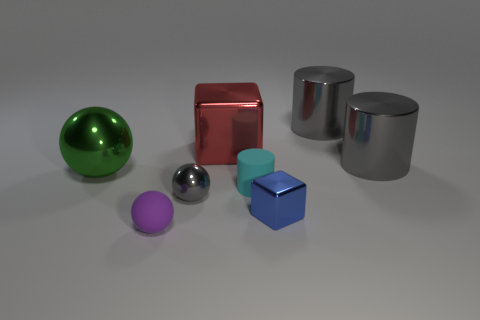There is a gray thing that is the same shape as the large green thing; what material is it?
Provide a short and direct response. Metal. Are there any small objects that have the same material as the red block?
Offer a terse response. Yes. There is a matte object right of the tiny matte object that is in front of the small cylinder; is there a green sphere right of it?
Your answer should be very brief. No. There is a blue metal object that is the same size as the purple ball; what is its shape?
Offer a very short reply. Cube. There is a shiny ball in front of the tiny cyan matte object; is its size the same as the metallic cube that is left of the small cyan cylinder?
Ensure brevity in your answer.  No. How many large gray metallic objects are there?
Offer a very short reply. 2. There is a object behind the cube that is behind the big cylinder in front of the big block; what is its size?
Ensure brevity in your answer.  Large. Is the color of the small block the same as the big block?
Your answer should be compact. No. Is there any other thing that has the same size as the red shiny thing?
Make the answer very short. Yes. What number of large balls are in front of the small purple matte thing?
Offer a terse response. 0. 